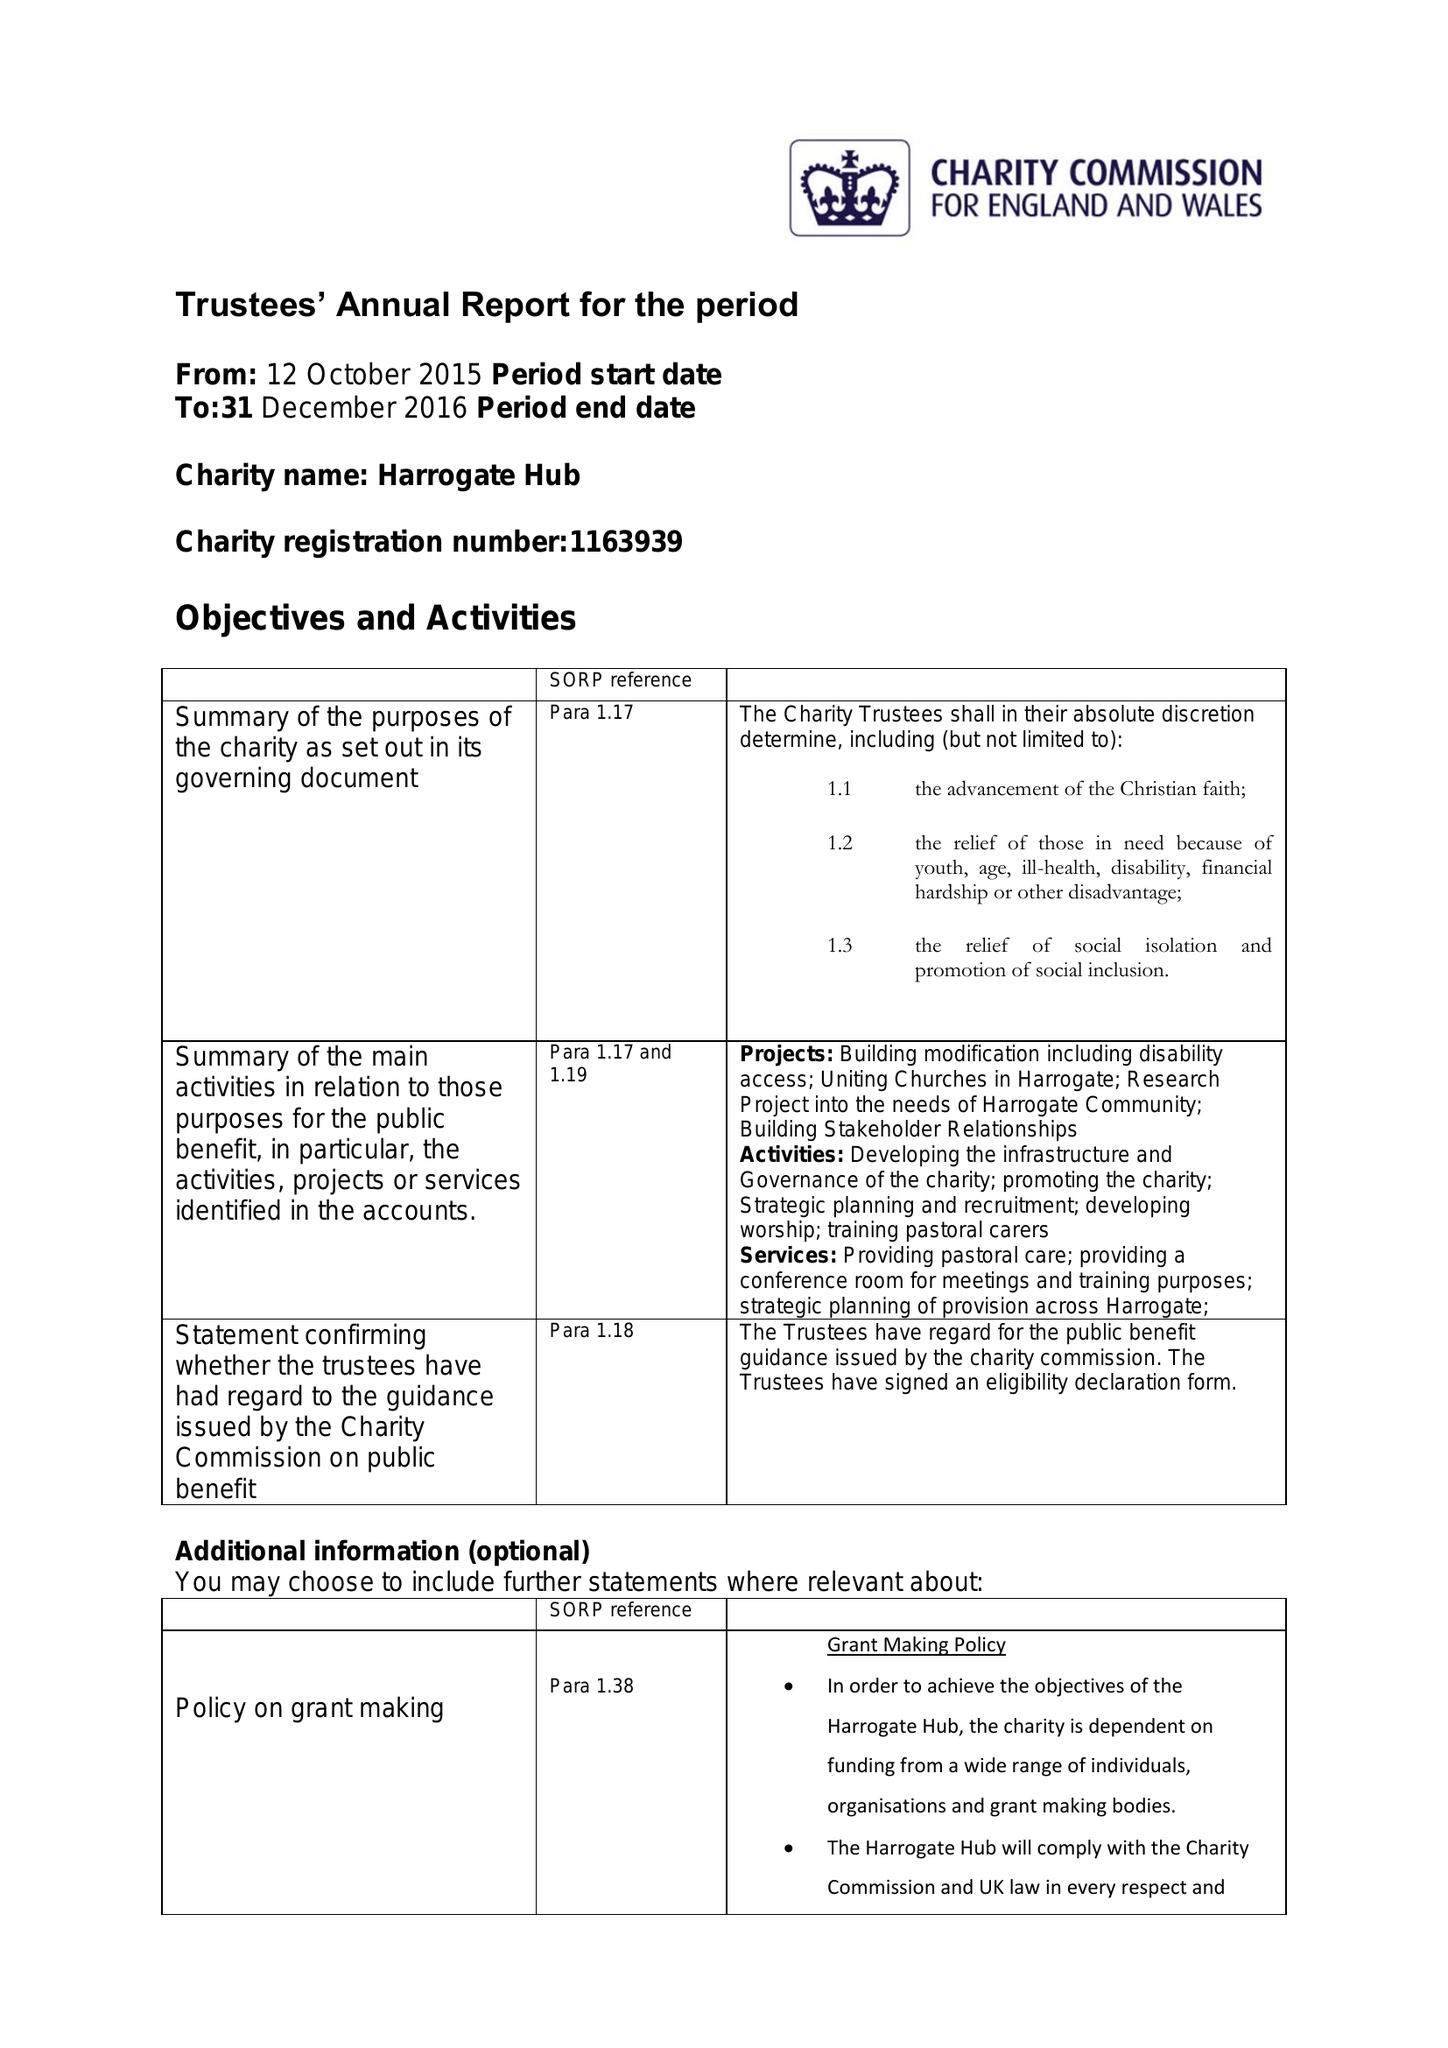What is the value for the income_annually_in_british_pounds?
Answer the question using a single word or phrase. 660256.00 